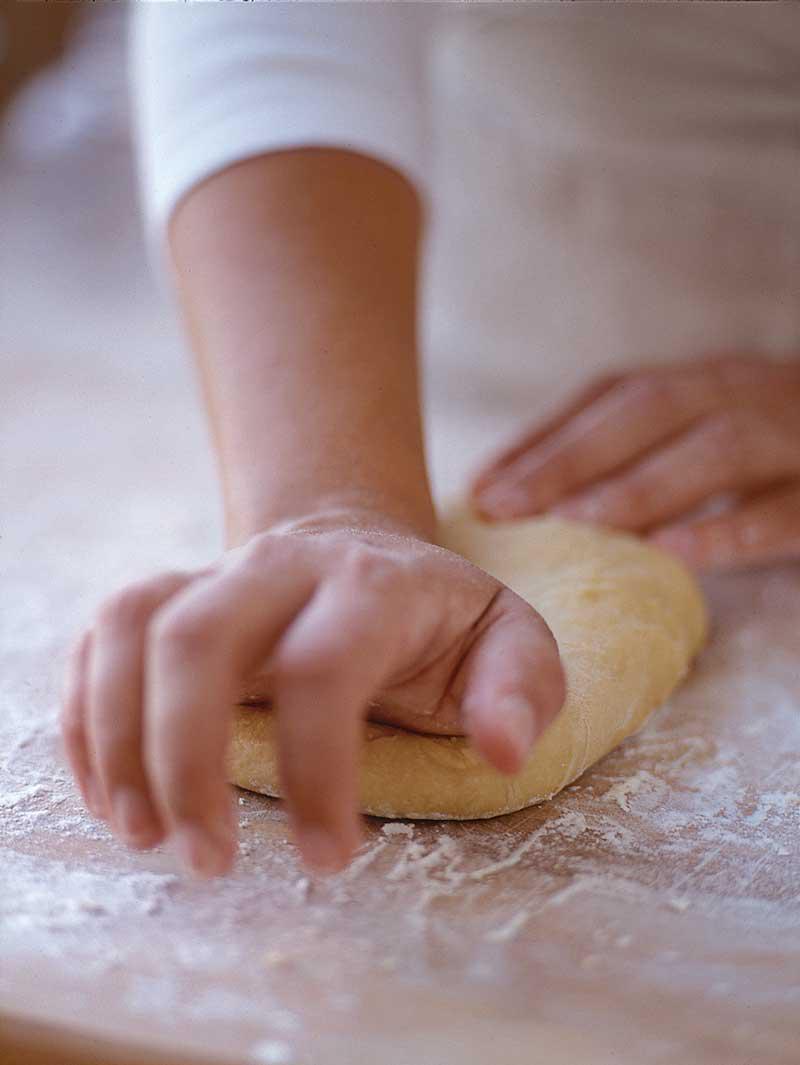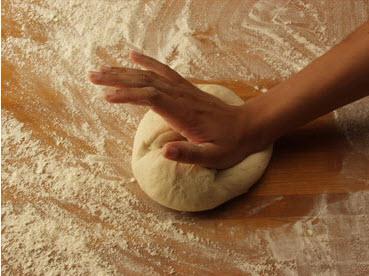The first image is the image on the left, the second image is the image on the right. Evaluate the accuracy of this statement regarding the images: "There are three hands visible.". Is it true? Answer yes or no. Yes. The first image is the image on the left, the second image is the image on the right. Examine the images to the left and right. Is the description "The heel of a hand is punching down a ball of dough on a floured surface in the right image." accurate? Answer yes or no. Yes. 